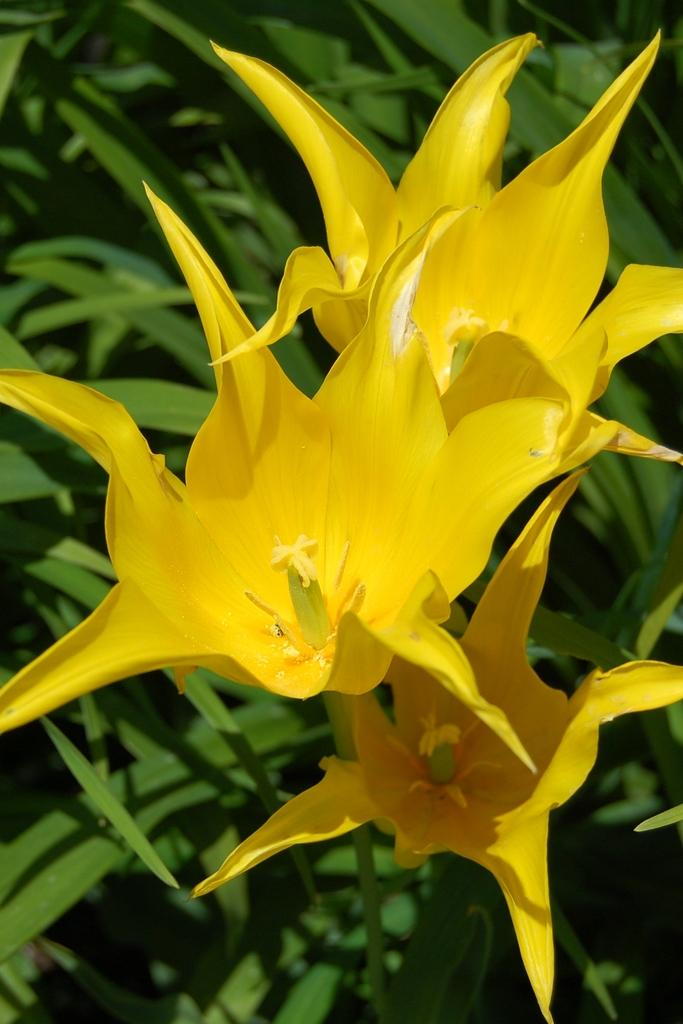What type of flora can be seen in the image? There are flowers in the image. Can you describe the background of the image? There are plants behind the flowers in the image. What type of agreement is being signed by the flowers in the image? There is no agreement being signed in the image, as flowers are inanimate objects and cannot sign agreements. 